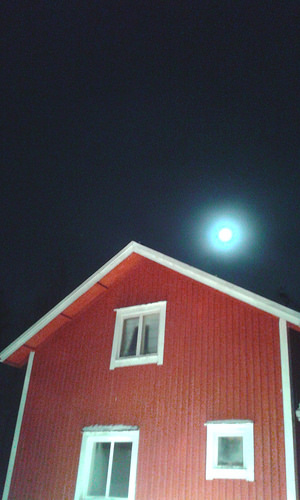<image>
Is there a moon on the house? No. The moon is not positioned on the house. They may be near each other, but the moon is not supported by or resting on top of the house. Is the moon in front of the house? No. The moon is not in front of the house. The spatial positioning shows a different relationship between these objects. Is there a sun above the house? Yes. The sun is positioned above the house in the vertical space, higher up in the scene. 